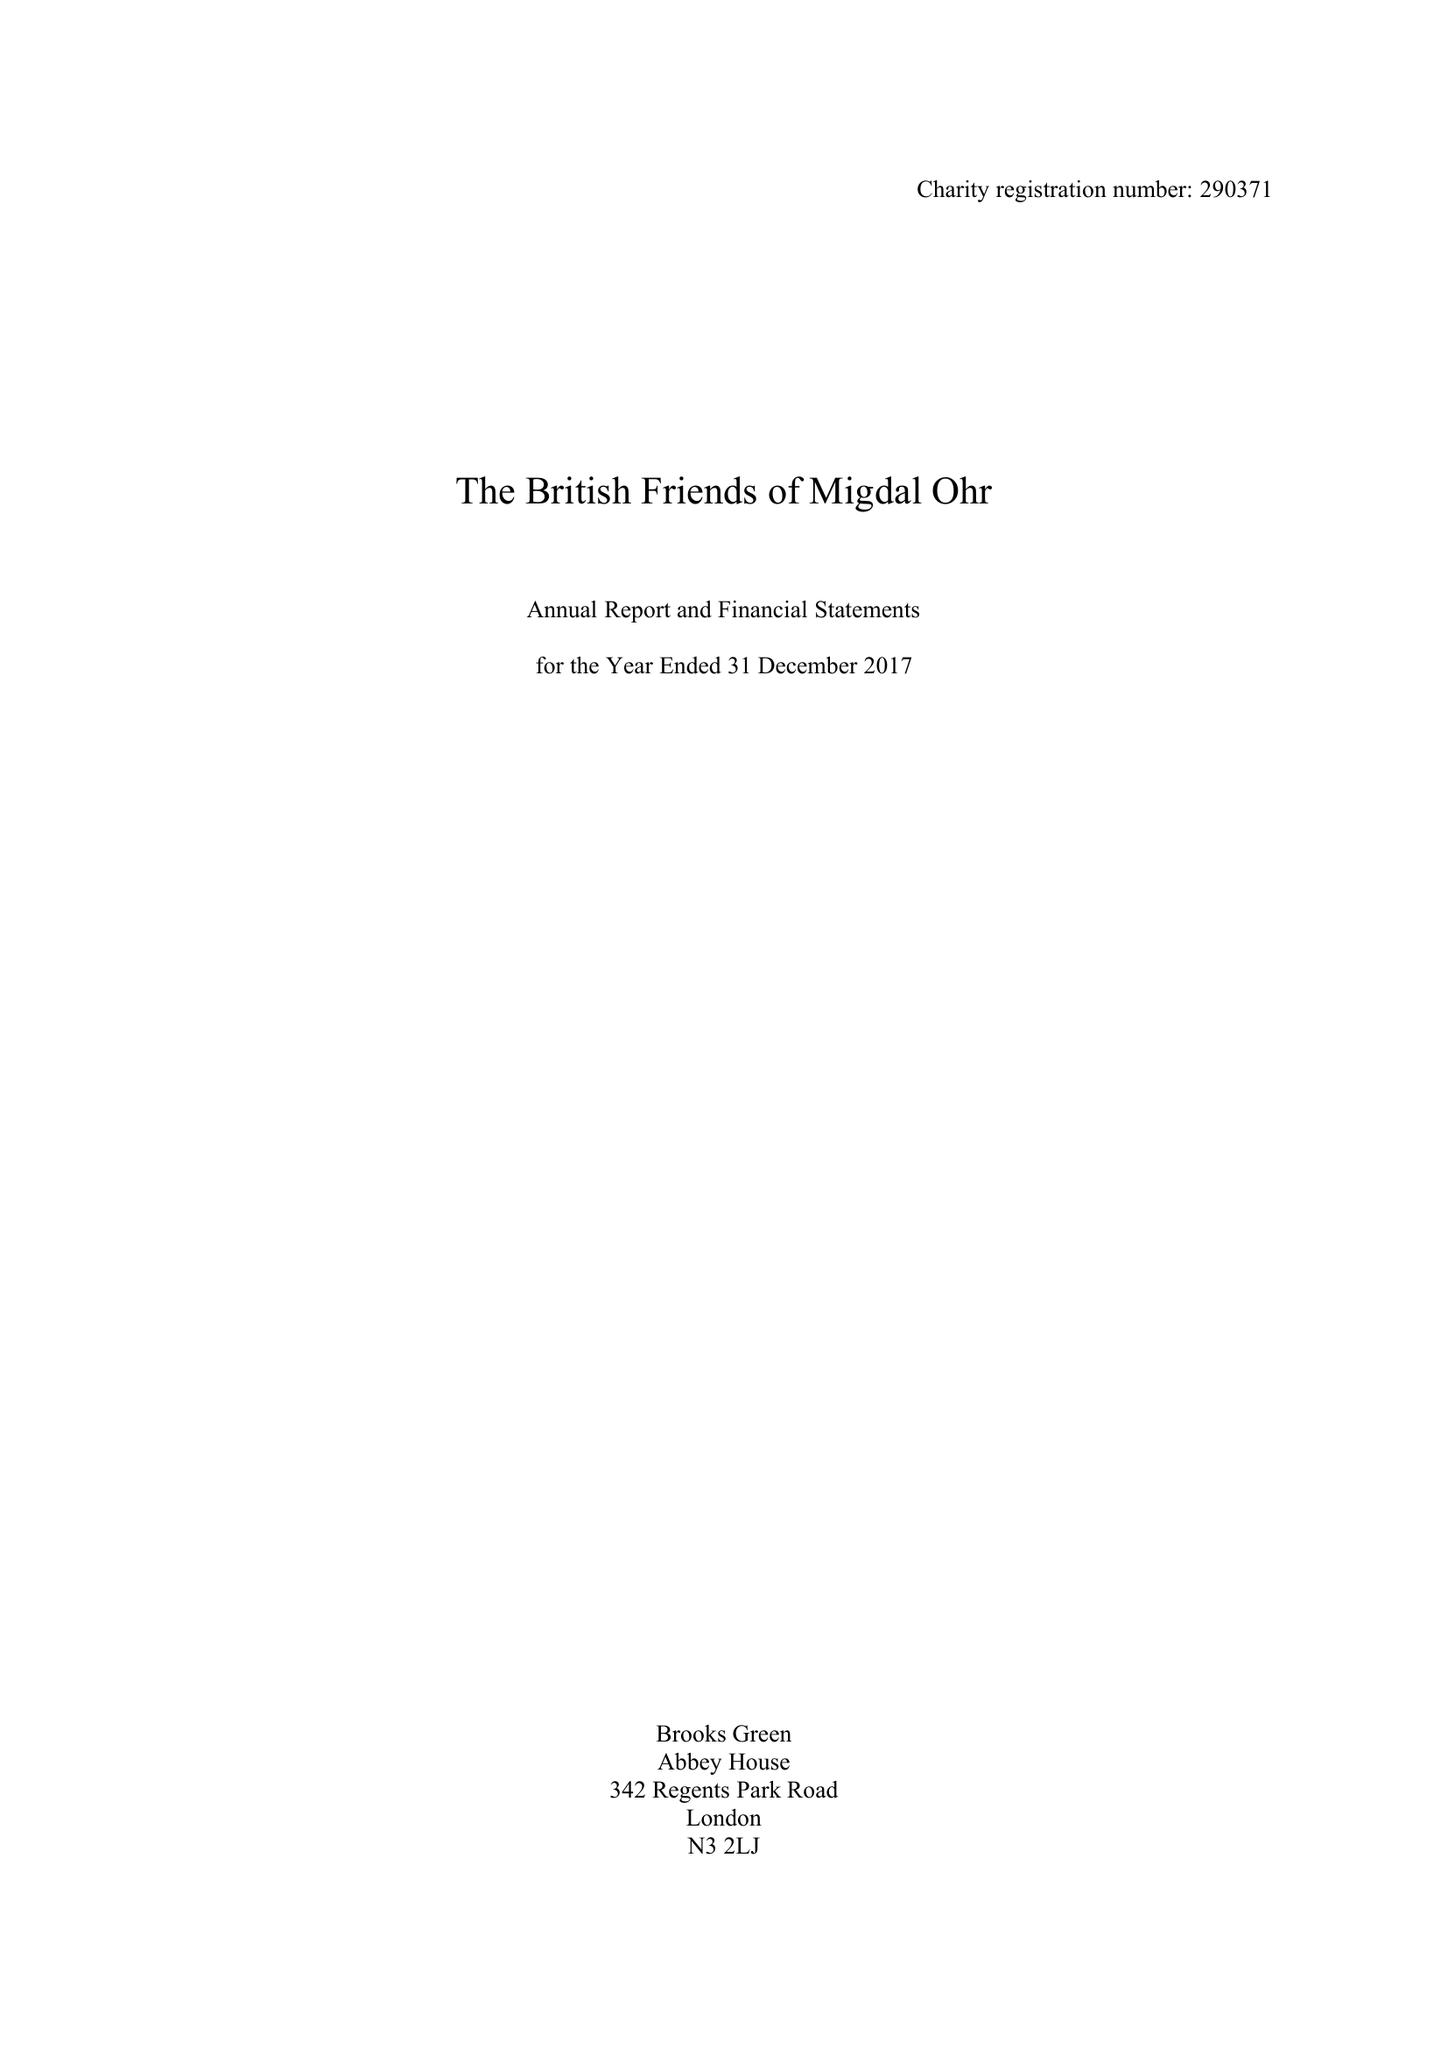What is the value for the charity_number?
Answer the question using a single word or phrase. 290371 